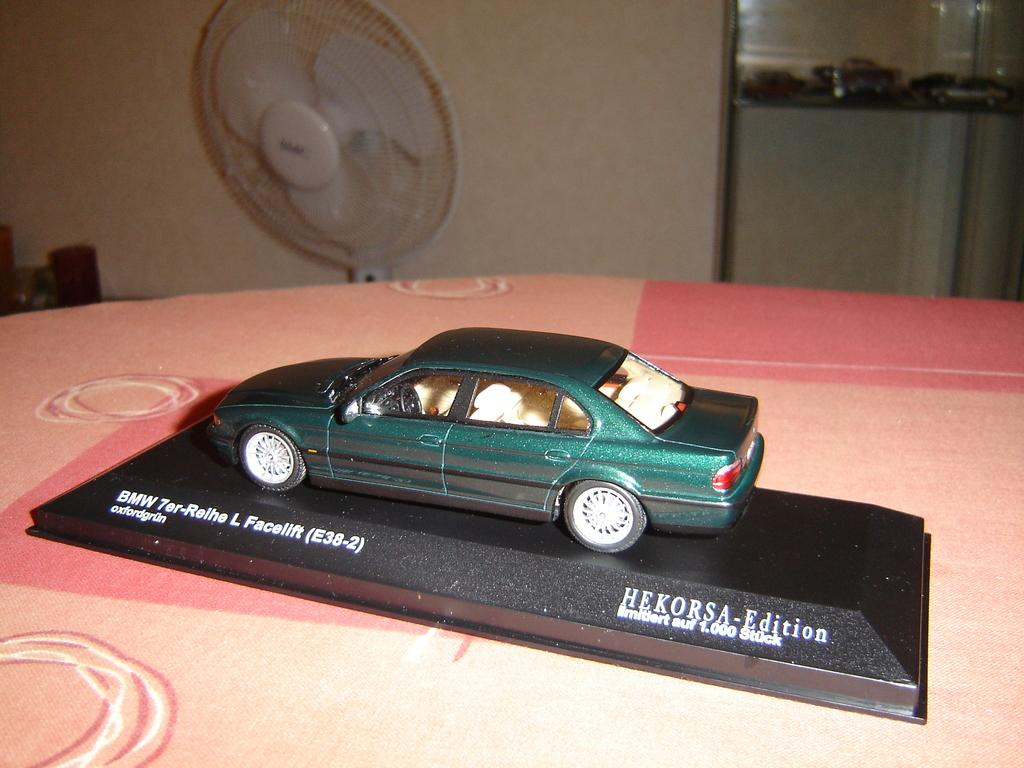What is the main subject of the image? There is a car on a black object in the image. Where is the black object located? The black object is on a table. What can be seen in the background of the image? There is a table fan and a wall in the background of the image, along with other objects. Can you hear the guitar start to cry in the image? There is no guitar or crying sound present in the image. 